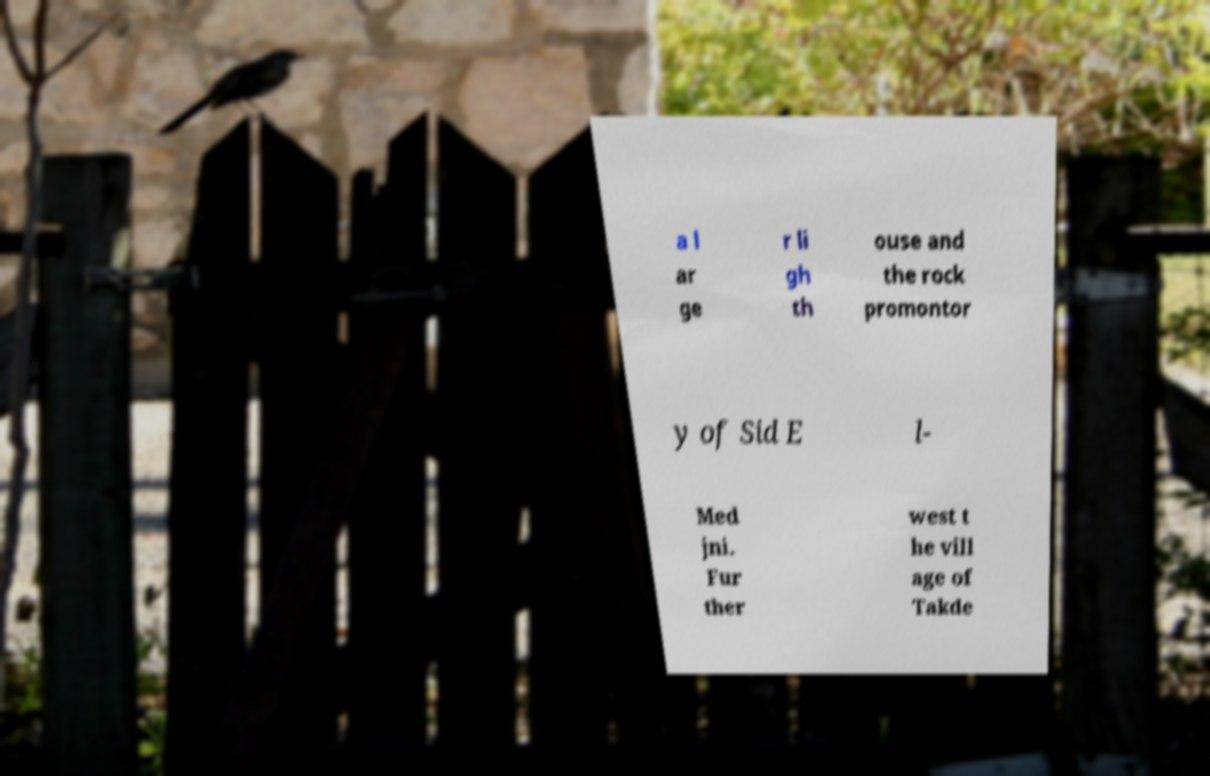Could you assist in decoding the text presented in this image and type it out clearly? a l ar ge r li gh th ouse and the rock promontor y of Sid E l- Med jni. Fur ther west t he vill age of Takde 